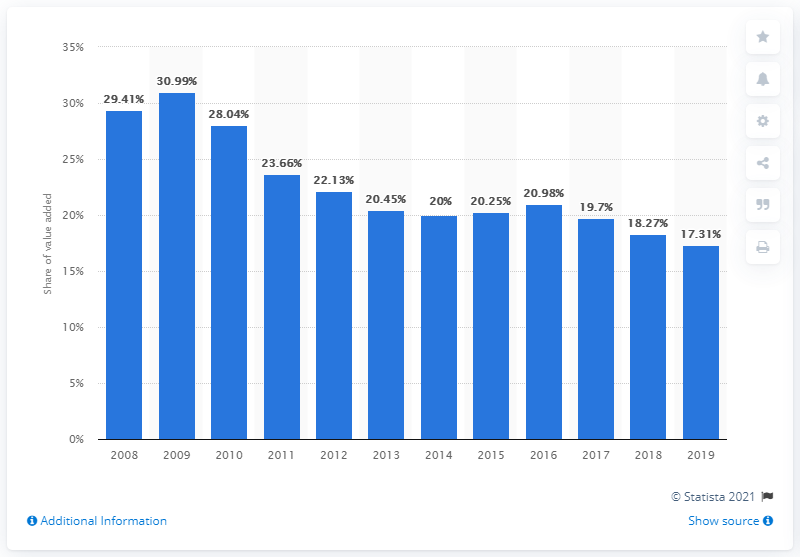Identify some key points in this picture. In 2008, the agricultural, forestry, and fishing sector contributed 29.41% to Ghana's GDP. 